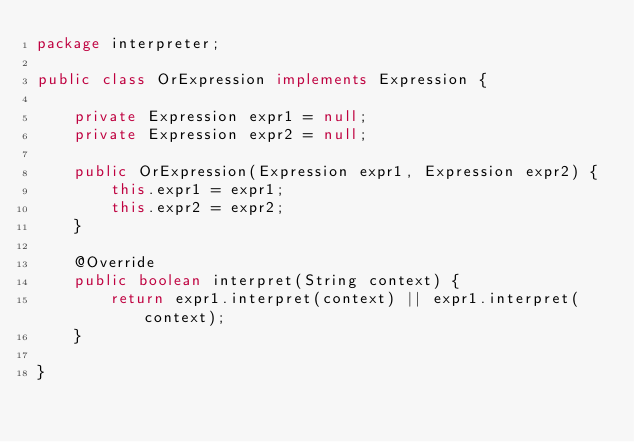<code> <loc_0><loc_0><loc_500><loc_500><_Java_>package interpreter;

public class OrExpression implements Expression {

    private Expression expr1 = null;
    private Expression expr2 = null;

    public OrExpression(Expression expr1, Expression expr2) {
        this.expr1 = expr1;
        this.expr2 = expr2;
    }

    @Override
    public boolean interpret(String context) {
        return expr1.interpret(context) || expr1.interpret(context);
    }

}
</code> 